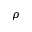<formula> <loc_0><loc_0><loc_500><loc_500>\rho</formula> 